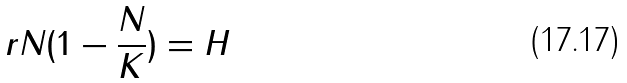<formula> <loc_0><loc_0><loc_500><loc_500>r N ( 1 - \frac { N } { K } ) = H</formula> 